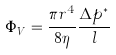<formula> <loc_0><loc_0><loc_500><loc_500>\Phi _ { V } = \frac { \pi r ^ { 4 } } { 8 \eta } \frac { \Delta p ^ { * } } { l }</formula> 